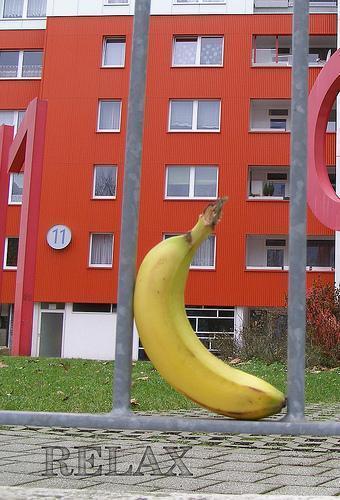How many bars of the fence are visible?
Give a very brief answer. 2. How many yellow banana do you see in the picture?
Give a very brief answer. 1. How many orange fruits are there?
Give a very brief answer. 0. 